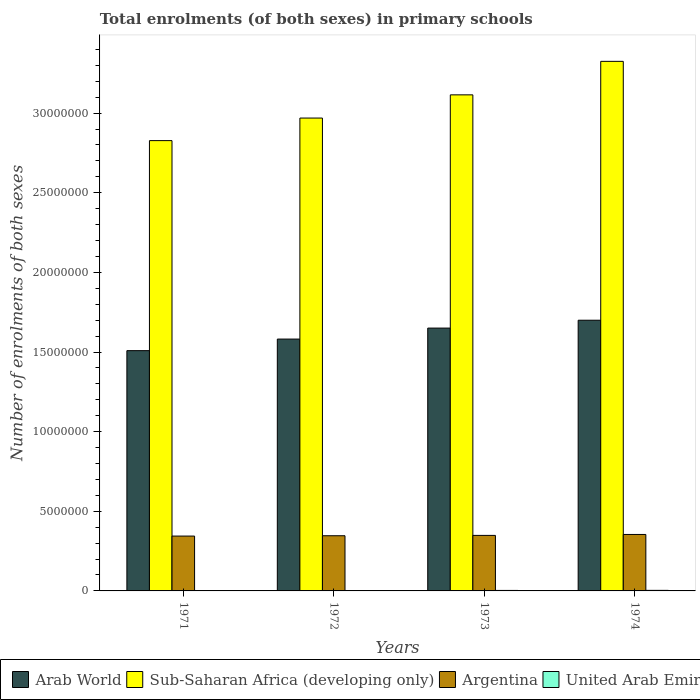How many different coloured bars are there?
Provide a succinct answer. 4. Are the number of bars on each tick of the X-axis equal?
Offer a very short reply. Yes. How many bars are there on the 1st tick from the left?
Your answer should be compact. 4. What is the label of the 4th group of bars from the left?
Provide a succinct answer. 1974. In how many cases, is the number of bars for a given year not equal to the number of legend labels?
Provide a short and direct response. 0. What is the number of enrolments in primary schools in United Arab Emirates in 1974?
Make the answer very short. 3.47e+04. Across all years, what is the maximum number of enrolments in primary schools in United Arab Emirates?
Provide a succinct answer. 3.47e+04. Across all years, what is the minimum number of enrolments in primary schools in Sub-Saharan Africa (developing only)?
Ensure brevity in your answer.  2.83e+07. In which year was the number of enrolments in primary schools in United Arab Emirates maximum?
Offer a very short reply. 1974. In which year was the number of enrolments in primary schools in Arab World minimum?
Provide a succinct answer. 1971. What is the total number of enrolments in primary schools in Argentina in the graph?
Provide a short and direct response. 1.39e+07. What is the difference between the number of enrolments in primary schools in United Arab Emirates in 1973 and that in 1974?
Offer a terse response. -4236. What is the difference between the number of enrolments in primary schools in Sub-Saharan Africa (developing only) in 1973 and the number of enrolments in primary schools in Argentina in 1971?
Provide a succinct answer. 2.77e+07. What is the average number of enrolments in primary schools in Arab World per year?
Your answer should be compact. 1.61e+07. In the year 1973, what is the difference between the number of enrolments in primary schools in Sub-Saharan Africa (developing only) and number of enrolments in primary schools in United Arab Emirates?
Offer a terse response. 3.11e+07. What is the ratio of the number of enrolments in primary schools in Arab World in 1973 to that in 1974?
Offer a terse response. 0.97. Is the number of enrolments in primary schools in Sub-Saharan Africa (developing only) in 1972 less than that in 1973?
Keep it short and to the point. Yes. Is the difference between the number of enrolments in primary schools in Sub-Saharan Africa (developing only) in 1972 and 1974 greater than the difference between the number of enrolments in primary schools in United Arab Emirates in 1972 and 1974?
Keep it short and to the point. No. What is the difference between the highest and the second highest number of enrolments in primary schools in Argentina?
Provide a succinct answer. 5.91e+04. What is the difference between the highest and the lowest number of enrolments in primary schools in Argentina?
Keep it short and to the point. 1.01e+05. In how many years, is the number of enrolments in primary schools in Arab World greater than the average number of enrolments in primary schools in Arab World taken over all years?
Provide a succinct answer. 2. What does the 3rd bar from the left in 1972 represents?
Your response must be concise. Argentina. What does the 4th bar from the right in 1971 represents?
Your answer should be very brief. Arab World. Are the values on the major ticks of Y-axis written in scientific E-notation?
Provide a succinct answer. No. Does the graph contain any zero values?
Ensure brevity in your answer.  No. Does the graph contain grids?
Your answer should be very brief. No. Where does the legend appear in the graph?
Offer a terse response. Bottom left. How many legend labels are there?
Your response must be concise. 4. How are the legend labels stacked?
Your answer should be compact. Horizontal. What is the title of the graph?
Your answer should be very brief. Total enrolments (of both sexes) in primary schools. Does "Burundi" appear as one of the legend labels in the graph?
Ensure brevity in your answer.  No. What is the label or title of the X-axis?
Provide a short and direct response. Years. What is the label or title of the Y-axis?
Offer a very short reply. Number of enrolments of both sexes. What is the Number of enrolments of both sexes in Arab World in 1971?
Provide a succinct answer. 1.51e+07. What is the Number of enrolments of both sexes of Sub-Saharan Africa (developing only) in 1971?
Your answer should be compact. 2.83e+07. What is the Number of enrolments of both sexes of Argentina in 1971?
Make the answer very short. 3.44e+06. What is the Number of enrolments of both sexes in United Arab Emirates in 1971?
Offer a terse response. 2.20e+04. What is the Number of enrolments of both sexes of Arab World in 1972?
Keep it short and to the point. 1.58e+07. What is the Number of enrolments of both sexes in Sub-Saharan Africa (developing only) in 1972?
Ensure brevity in your answer.  2.97e+07. What is the Number of enrolments of both sexes of Argentina in 1972?
Provide a short and direct response. 3.46e+06. What is the Number of enrolments of both sexes of United Arab Emirates in 1972?
Ensure brevity in your answer.  2.61e+04. What is the Number of enrolments of both sexes in Arab World in 1973?
Give a very brief answer. 1.65e+07. What is the Number of enrolments of both sexes in Sub-Saharan Africa (developing only) in 1973?
Your answer should be very brief. 3.11e+07. What is the Number of enrolments of both sexes of Argentina in 1973?
Your answer should be compact. 3.49e+06. What is the Number of enrolments of both sexes of United Arab Emirates in 1973?
Provide a short and direct response. 3.05e+04. What is the Number of enrolments of both sexes of Arab World in 1974?
Offer a terse response. 1.70e+07. What is the Number of enrolments of both sexes of Sub-Saharan Africa (developing only) in 1974?
Offer a very short reply. 3.32e+07. What is the Number of enrolments of both sexes of Argentina in 1974?
Give a very brief answer. 3.54e+06. What is the Number of enrolments of both sexes in United Arab Emirates in 1974?
Your answer should be compact. 3.47e+04. Across all years, what is the maximum Number of enrolments of both sexes of Arab World?
Your answer should be very brief. 1.70e+07. Across all years, what is the maximum Number of enrolments of both sexes in Sub-Saharan Africa (developing only)?
Give a very brief answer. 3.32e+07. Across all years, what is the maximum Number of enrolments of both sexes in Argentina?
Your response must be concise. 3.54e+06. Across all years, what is the maximum Number of enrolments of both sexes of United Arab Emirates?
Make the answer very short. 3.47e+04. Across all years, what is the minimum Number of enrolments of both sexes in Arab World?
Keep it short and to the point. 1.51e+07. Across all years, what is the minimum Number of enrolments of both sexes in Sub-Saharan Africa (developing only)?
Give a very brief answer. 2.83e+07. Across all years, what is the minimum Number of enrolments of both sexes of Argentina?
Your answer should be compact. 3.44e+06. Across all years, what is the minimum Number of enrolments of both sexes of United Arab Emirates?
Ensure brevity in your answer.  2.20e+04. What is the total Number of enrolments of both sexes in Arab World in the graph?
Make the answer very short. 6.44e+07. What is the total Number of enrolments of both sexes in Sub-Saharan Africa (developing only) in the graph?
Your answer should be very brief. 1.22e+08. What is the total Number of enrolments of both sexes of Argentina in the graph?
Your response must be concise. 1.39e+07. What is the total Number of enrolments of both sexes of United Arab Emirates in the graph?
Your answer should be very brief. 1.13e+05. What is the difference between the Number of enrolments of both sexes of Arab World in 1971 and that in 1972?
Give a very brief answer. -7.27e+05. What is the difference between the Number of enrolments of both sexes of Sub-Saharan Africa (developing only) in 1971 and that in 1972?
Make the answer very short. -1.42e+06. What is the difference between the Number of enrolments of both sexes of Argentina in 1971 and that in 1972?
Provide a succinct answer. -2.08e+04. What is the difference between the Number of enrolments of both sexes in United Arab Emirates in 1971 and that in 1972?
Your answer should be compact. -4121. What is the difference between the Number of enrolments of both sexes in Arab World in 1971 and that in 1973?
Provide a succinct answer. -1.42e+06. What is the difference between the Number of enrolments of both sexes of Sub-Saharan Africa (developing only) in 1971 and that in 1973?
Ensure brevity in your answer.  -2.87e+06. What is the difference between the Number of enrolments of both sexes in Argentina in 1971 and that in 1973?
Offer a terse response. -4.18e+04. What is the difference between the Number of enrolments of both sexes in United Arab Emirates in 1971 and that in 1973?
Ensure brevity in your answer.  -8486. What is the difference between the Number of enrolments of both sexes of Arab World in 1971 and that in 1974?
Your answer should be very brief. -1.91e+06. What is the difference between the Number of enrolments of both sexes of Sub-Saharan Africa (developing only) in 1971 and that in 1974?
Offer a very short reply. -4.98e+06. What is the difference between the Number of enrolments of both sexes of Argentina in 1971 and that in 1974?
Ensure brevity in your answer.  -1.01e+05. What is the difference between the Number of enrolments of both sexes of United Arab Emirates in 1971 and that in 1974?
Offer a very short reply. -1.27e+04. What is the difference between the Number of enrolments of both sexes in Arab World in 1972 and that in 1973?
Your response must be concise. -6.90e+05. What is the difference between the Number of enrolments of both sexes in Sub-Saharan Africa (developing only) in 1972 and that in 1973?
Offer a terse response. -1.46e+06. What is the difference between the Number of enrolments of both sexes of Argentina in 1972 and that in 1973?
Keep it short and to the point. -2.11e+04. What is the difference between the Number of enrolments of both sexes of United Arab Emirates in 1972 and that in 1973?
Ensure brevity in your answer.  -4365. What is the difference between the Number of enrolments of both sexes in Arab World in 1972 and that in 1974?
Provide a succinct answer. -1.18e+06. What is the difference between the Number of enrolments of both sexes of Sub-Saharan Africa (developing only) in 1972 and that in 1974?
Provide a succinct answer. -3.56e+06. What is the difference between the Number of enrolments of both sexes of Argentina in 1972 and that in 1974?
Make the answer very short. -8.02e+04. What is the difference between the Number of enrolments of both sexes in United Arab Emirates in 1972 and that in 1974?
Offer a very short reply. -8601. What is the difference between the Number of enrolments of both sexes of Arab World in 1973 and that in 1974?
Keep it short and to the point. -4.94e+05. What is the difference between the Number of enrolments of both sexes of Sub-Saharan Africa (developing only) in 1973 and that in 1974?
Keep it short and to the point. -2.10e+06. What is the difference between the Number of enrolments of both sexes in Argentina in 1973 and that in 1974?
Your answer should be very brief. -5.91e+04. What is the difference between the Number of enrolments of both sexes in United Arab Emirates in 1973 and that in 1974?
Provide a succinct answer. -4236. What is the difference between the Number of enrolments of both sexes of Arab World in 1971 and the Number of enrolments of both sexes of Sub-Saharan Africa (developing only) in 1972?
Offer a very short reply. -1.46e+07. What is the difference between the Number of enrolments of both sexes in Arab World in 1971 and the Number of enrolments of both sexes in Argentina in 1972?
Your answer should be very brief. 1.16e+07. What is the difference between the Number of enrolments of both sexes of Arab World in 1971 and the Number of enrolments of both sexes of United Arab Emirates in 1972?
Your answer should be compact. 1.51e+07. What is the difference between the Number of enrolments of both sexes in Sub-Saharan Africa (developing only) in 1971 and the Number of enrolments of both sexes in Argentina in 1972?
Keep it short and to the point. 2.48e+07. What is the difference between the Number of enrolments of both sexes in Sub-Saharan Africa (developing only) in 1971 and the Number of enrolments of both sexes in United Arab Emirates in 1972?
Provide a succinct answer. 2.82e+07. What is the difference between the Number of enrolments of both sexes of Argentina in 1971 and the Number of enrolments of both sexes of United Arab Emirates in 1972?
Give a very brief answer. 3.42e+06. What is the difference between the Number of enrolments of both sexes of Arab World in 1971 and the Number of enrolments of both sexes of Sub-Saharan Africa (developing only) in 1973?
Your response must be concise. -1.61e+07. What is the difference between the Number of enrolments of both sexes of Arab World in 1971 and the Number of enrolments of both sexes of Argentina in 1973?
Your answer should be compact. 1.16e+07. What is the difference between the Number of enrolments of both sexes in Arab World in 1971 and the Number of enrolments of both sexes in United Arab Emirates in 1973?
Offer a very short reply. 1.51e+07. What is the difference between the Number of enrolments of both sexes of Sub-Saharan Africa (developing only) in 1971 and the Number of enrolments of both sexes of Argentina in 1973?
Your response must be concise. 2.48e+07. What is the difference between the Number of enrolments of both sexes in Sub-Saharan Africa (developing only) in 1971 and the Number of enrolments of both sexes in United Arab Emirates in 1973?
Keep it short and to the point. 2.82e+07. What is the difference between the Number of enrolments of both sexes of Argentina in 1971 and the Number of enrolments of both sexes of United Arab Emirates in 1973?
Provide a succinct answer. 3.41e+06. What is the difference between the Number of enrolments of both sexes in Arab World in 1971 and the Number of enrolments of both sexes in Sub-Saharan Africa (developing only) in 1974?
Your answer should be very brief. -1.82e+07. What is the difference between the Number of enrolments of both sexes of Arab World in 1971 and the Number of enrolments of both sexes of Argentina in 1974?
Make the answer very short. 1.15e+07. What is the difference between the Number of enrolments of both sexes of Arab World in 1971 and the Number of enrolments of both sexes of United Arab Emirates in 1974?
Your answer should be compact. 1.51e+07. What is the difference between the Number of enrolments of both sexes in Sub-Saharan Africa (developing only) in 1971 and the Number of enrolments of both sexes in Argentina in 1974?
Your answer should be compact. 2.47e+07. What is the difference between the Number of enrolments of both sexes in Sub-Saharan Africa (developing only) in 1971 and the Number of enrolments of both sexes in United Arab Emirates in 1974?
Offer a terse response. 2.82e+07. What is the difference between the Number of enrolments of both sexes of Argentina in 1971 and the Number of enrolments of both sexes of United Arab Emirates in 1974?
Provide a succinct answer. 3.41e+06. What is the difference between the Number of enrolments of both sexes of Arab World in 1972 and the Number of enrolments of both sexes of Sub-Saharan Africa (developing only) in 1973?
Ensure brevity in your answer.  -1.53e+07. What is the difference between the Number of enrolments of both sexes in Arab World in 1972 and the Number of enrolments of both sexes in Argentina in 1973?
Give a very brief answer. 1.23e+07. What is the difference between the Number of enrolments of both sexes of Arab World in 1972 and the Number of enrolments of both sexes of United Arab Emirates in 1973?
Your answer should be compact. 1.58e+07. What is the difference between the Number of enrolments of both sexes in Sub-Saharan Africa (developing only) in 1972 and the Number of enrolments of both sexes in Argentina in 1973?
Ensure brevity in your answer.  2.62e+07. What is the difference between the Number of enrolments of both sexes of Sub-Saharan Africa (developing only) in 1972 and the Number of enrolments of both sexes of United Arab Emirates in 1973?
Your answer should be compact. 2.97e+07. What is the difference between the Number of enrolments of both sexes of Argentina in 1972 and the Number of enrolments of both sexes of United Arab Emirates in 1973?
Make the answer very short. 3.43e+06. What is the difference between the Number of enrolments of both sexes in Arab World in 1972 and the Number of enrolments of both sexes in Sub-Saharan Africa (developing only) in 1974?
Your response must be concise. -1.74e+07. What is the difference between the Number of enrolments of both sexes in Arab World in 1972 and the Number of enrolments of both sexes in Argentina in 1974?
Your answer should be compact. 1.23e+07. What is the difference between the Number of enrolments of both sexes in Arab World in 1972 and the Number of enrolments of both sexes in United Arab Emirates in 1974?
Your response must be concise. 1.58e+07. What is the difference between the Number of enrolments of both sexes of Sub-Saharan Africa (developing only) in 1972 and the Number of enrolments of both sexes of Argentina in 1974?
Offer a terse response. 2.61e+07. What is the difference between the Number of enrolments of both sexes in Sub-Saharan Africa (developing only) in 1972 and the Number of enrolments of both sexes in United Arab Emirates in 1974?
Provide a succinct answer. 2.97e+07. What is the difference between the Number of enrolments of both sexes of Argentina in 1972 and the Number of enrolments of both sexes of United Arab Emirates in 1974?
Your answer should be compact. 3.43e+06. What is the difference between the Number of enrolments of both sexes of Arab World in 1973 and the Number of enrolments of both sexes of Sub-Saharan Africa (developing only) in 1974?
Make the answer very short. -1.67e+07. What is the difference between the Number of enrolments of both sexes of Arab World in 1973 and the Number of enrolments of both sexes of Argentina in 1974?
Keep it short and to the point. 1.30e+07. What is the difference between the Number of enrolments of both sexes of Arab World in 1973 and the Number of enrolments of both sexes of United Arab Emirates in 1974?
Ensure brevity in your answer.  1.65e+07. What is the difference between the Number of enrolments of both sexes of Sub-Saharan Africa (developing only) in 1973 and the Number of enrolments of both sexes of Argentina in 1974?
Offer a terse response. 2.76e+07. What is the difference between the Number of enrolments of both sexes in Sub-Saharan Africa (developing only) in 1973 and the Number of enrolments of both sexes in United Arab Emirates in 1974?
Your answer should be compact. 3.11e+07. What is the difference between the Number of enrolments of both sexes in Argentina in 1973 and the Number of enrolments of both sexes in United Arab Emirates in 1974?
Give a very brief answer. 3.45e+06. What is the average Number of enrolments of both sexes of Arab World per year?
Give a very brief answer. 1.61e+07. What is the average Number of enrolments of both sexes in Sub-Saharan Africa (developing only) per year?
Make the answer very short. 3.06e+07. What is the average Number of enrolments of both sexes in Argentina per year?
Your response must be concise. 3.48e+06. What is the average Number of enrolments of both sexes of United Arab Emirates per year?
Offer a terse response. 2.83e+04. In the year 1971, what is the difference between the Number of enrolments of both sexes in Arab World and Number of enrolments of both sexes in Sub-Saharan Africa (developing only)?
Ensure brevity in your answer.  -1.32e+07. In the year 1971, what is the difference between the Number of enrolments of both sexes of Arab World and Number of enrolments of both sexes of Argentina?
Ensure brevity in your answer.  1.16e+07. In the year 1971, what is the difference between the Number of enrolments of both sexes in Arab World and Number of enrolments of both sexes in United Arab Emirates?
Your answer should be very brief. 1.51e+07. In the year 1971, what is the difference between the Number of enrolments of both sexes of Sub-Saharan Africa (developing only) and Number of enrolments of both sexes of Argentina?
Your answer should be very brief. 2.48e+07. In the year 1971, what is the difference between the Number of enrolments of both sexes of Sub-Saharan Africa (developing only) and Number of enrolments of both sexes of United Arab Emirates?
Provide a succinct answer. 2.83e+07. In the year 1971, what is the difference between the Number of enrolments of both sexes in Argentina and Number of enrolments of both sexes in United Arab Emirates?
Your answer should be compact. 3.42e+06. In the year 1972, what is the difference between the Number of enrolments of both sexes in Arab World and Number of enrolments of both sexes in Sub-Saharan Africa (developing only)?
Give a very brief answer. -1.39e+07. In the year 1972, what is the difference between the Number of enrolments of both sexes of Arab World and Number of enrolments of both sexes of Argentina?
Your response must be concise. 1.23e+07. In the year 1972, what is the difference between the Number of enrolments of both sexes of Arab World and Number of enrolments of both sexes of United Arab Emirates?
Offer a terse response. 1.58e+07. In the year 1972, what is the difference between the Number of enrolments of both sexes in Sub-Saharan Africa (developing only) and Number of enrolments of both sexes in Argentina?
Your answer should be very brief. 2.62e+07. In the year 1972, what is the difference between the Number of enrolments of both sexes of Sub-Saharan Africa (developing only) and Number of enrolments of both sexes of United Arab Emirates?
Provide a succinct answer. 2.97e+07. In the year 1972, what is the difference between the Number of enrolments of both sexes of Argentina and Number of enrolments of both sexes of United Arab Emirates?
Ensure brevity in your answer.  3.44e+06. In the year 1973, what is the difference between the Number of enrolments of both sexes in Arab World and Number of enrolments of both sexes in Sub-Saharan Africa (developing only)?
Your answer should be very brief. -1.46e+07. In the year 1973, what is the difference between the Number of enrolments of both sexes in Arab World and Number of enrolments of both sexes in Argentina?
Your answer should be compact. 1.30e+07. In the year 1973, what is the difference between the Number of enrolments of both sexes in Arab World and Number of enrolments of both sexes in United Arab Emirates?
Keep it short and to the point. 1.65e+07. In the year 1973, what is the difference between the Number of enrolments of both sexes of Sub-Saharan Africa (developing only) and Number of enrolments of both sexes of Argentina?
Keep it short and to the point. 2.77e+07. In the year 1973, what is the difference between the Number of enrolments of both sexes in Sub-Saharan Africa (developing only) and Number of enrolments of both sexes in United Arab Emirates?
Your answer should be very brief. 3.11e+07. In the year 1973, what is the difference between the Number of enrolments of both sexes in Argentina and Number of enrolments of both sexes in United Arab Emirates?
Make the answer very short. 3.46e+06. In the year 1974, what is the difference between the Number of enrolments of both sexes of Arab World and Number of enrolments of both sexes of Sub-Saharan Africa (developing only)?
Your answer should be compact. -1.63e+07. In the year 1974, what is the difference between the Number of enrolments of both sexes of Arab World and Number of enrolments of both sexes of Argentina?
Ensure brevity in your answer.  1.35e+07. In the year 1974, what is the difference between the Number of enrolments of both sexes in Arab World and Number of enrolments of both sexes in United Arab Emirates?
Your answer should be very brief. 1.70e+07. In the year 1974, what is the difference between the Number of enrolments of both sexes in Sub-Saharan Africa (developing only) and Number of enrolments of both sexes in Argentina?
Provide a succinct answer. 2.97e+07. In the year 1974, what is the difference between the Number of enrolments of both sexes of Sub-Saharan Africa (developing only) and Number of enrolments of both sexes of United Arab Emirates?
Your answer should be very brief. 3.32e+07. In the year 1974, what is the difference between the Number of enrolments of both sexes of Argentina and Number of enrolments of both sexes of United Arab Emirates?
Provide a short and direct response. 3.51e+06. What is the ratio of the Number of enrolments of both sexes of Arab World in 1971 to that in 1972?
Your answer should be compact. 0.95. What is the ratio of the Number of enrolments of both sexes in Sub-Saharan Africa (developing only) in 1971 to that in 1972?
Provide a succinct answer. 0.95. What is the ratio of the Number of enrolments of both sexes of United Arab Emirates in 1971 to that in 1972?
Make the answer very short. 0.84. What is the ratio of the Number of enrolments of both sexes of Arab World in 1971 to that in 1973?
Give a very brief answer. 0.91. What is the ratio of the Number of enrolments of both sexes of Sub-Saharan Africa (developing only) in 1971 to that in 1973?
Your answer should be compact. 0.91. What is the ratio of the Number of enrolments of both sexes of Argentina in 1971 to that in 1973?
Give a very brief answer. 0.99. What is the ratio of the Number of enrolments of both sexes of United Arab Emirates in 1971 to that in 1973?
Give a very brief answer. 0.72. What is the ratio of the Number of enrolments of both sexes of Arab World in 1971 to that in 1974?
Make the answer very short. 0.89. What is the ratio of the Number of enrolments of both sexes of Sub-Saharan Africa (developing only) in 1971 to that in 1974?
Provide a succinct answer. 0.85. What is the ratio of the Number of enrolments of both sexes in Argentina in 1971 to that in 1974?
Keep it short and to the point. 0.97. What is the ratio of the Number of enrolments of both sexes of United Arab Emirates in 1971 to that in 1974?
Your answer should be very brief. 0.63. What is the ratio of the Number of enrolments of both sexes of Arab World in 1972 to that in 1973?
Give a very brief answer. 0.96. What is the ratio of the Number of enrolments of both sexes in Sub-Saharan Africa (developing only) in 1972 to that in 1973?
Give a very brief answer. 0.95. What is the ratio of the Number of enrolments of both sexes of Argentina in 1972 to that in 1973?
Keep it short and to the point. 0.99. What is the ratio of the Number of enrolments of both sexes of United Arab Emirates in 1972 to that in 1973?
Provide a short and direct response. 0.86. What is the ratio of the Number of enrolments of both sexes in Arab World in 1972 to that in 1974?
Give a very brief answer. 0.93. What is the ratio of the Number of enrolments of both sexes of Sub-Saharan Africa (developing only) in 1972 to that in 1974?
Ensure brevity in your answer.  0.89. What is the ratio of the Number of enrolments of both sexes in Argentina in 1972 to that in 1974?
Keep it short and to the point. 0.98. What is the ratio of the Number of enrolments of both sexes in United Arab Emirates in 1972 to that in 1974?
Your answer should be very brief. 0.75. What is the ratio of the Number of enrolments of both sexes in Arab World in 1973 to that in 1974?
Keep it short and to the point. 0.97. What is the ratio of the Number of enrolments of both sexes in Sub-Saharan Africa (developing only) in 1973 to that in 1974?
Provide a succinct answer. 0.94. What is the ratio of the Number of enrolments of both sexes in Argentina in 1973 to that in 1974?
Ensure brevity in your answer.  0.98. What is the ratio of the Number of enrolments of both sexes in United Arab Emirates in 1973 to that in 1974?
Make the answer very short. 0.88. What is the difference between the highest and the second highest Number of enrolments of both sexes in Arab World?
Give a very brief answer. 4.94e+05. What is the difference between the highest and the second highest Number of enrolments of both sexes of Sub-Saharan Africa (developing only)?
Your answer should be very brief. 2.10e+06. What is the difference between the highest and the second highest Number of enrolments of both sexes of Argentina?
Provide a succinct answer. 5.91e+04. What is the difference between the highest and the second highest Number of enrolments of both sexes in United Arab Emirates?
Keep it short and to the point. 4236. What is the difference between the highest and the lowest Number of enrolments of both sexes of Arab World?
Give a very brief answer. 1.91e+06. What is the difference between the highest and the lowest Number of enrolments of both sexes of Sub-Saharan Africa (developing only)?
Your answer should be very brief. 4.98e+06. What is the difference between the highest and the lowest Number of enrolments of both sexes of Argentina?
Your answer should be compact. 1.01e+05. What is the difference between the highest and the lowest Number of enrolments of both sexes of United Arab Emirates?
Give a very brief answer. 1.27e+04. 